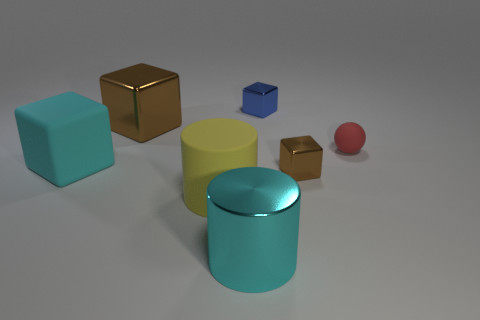How many cubes are to the right of the small cube that is behind the object that is right of the tiny brown shiny object?
Your response must be concise. 1. There is a cube on the left side of the large thing that is behind the cyan cube; what is its color?
Ensure brevity in your answer.  Cyan. Are there any brown balls that have the same size as the cyan metal cylinder?
Give a very brief answer. No. There is a tiny sphere that is right of the large cyan object that is left of the brown shiny thing behind the small red matte object; what is its material?
Offer a very short reply. Rubber. How many brown objects are behind the brown object in front of the tiny sphere?
Make the answer very short. 1. Does the cyan object in front of the yellow rubber thing have the same size as the small red object?
Your answer should be very brief. No. What number of tiny matte objects have the same shape as the large brown shiny thing?
Provide a short and direct response. 0. What is the shape of the small red rubber object?
Keep it short and to the point. Sphere. Are there an equal number of tiny red matte balls that are left of the big cyan matte object and large cyan spheres?
Your answer should be compact. Yes. Are there any other things that are the same material as the cyan cylinder?
Your response must be concise. Yes. 